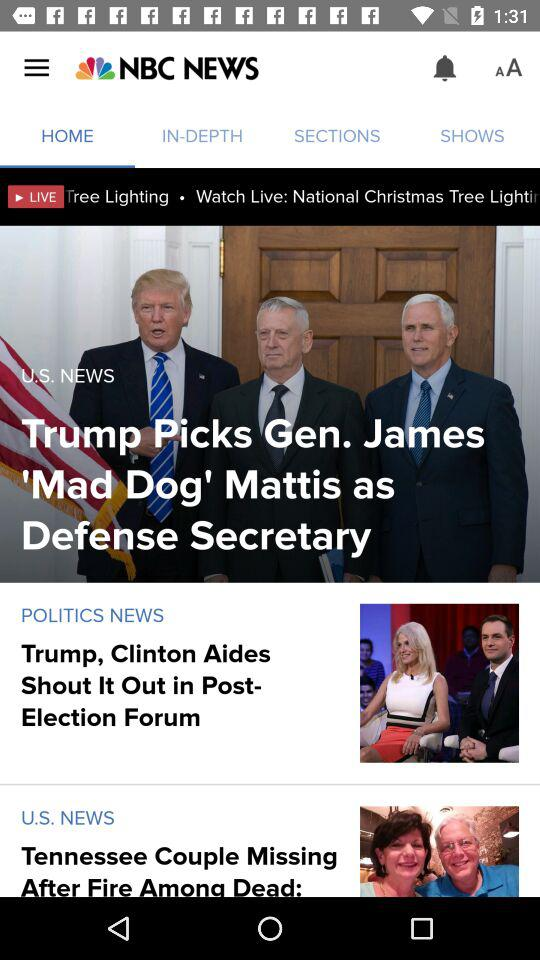Which tab is selected? The selected tab is "HOME". 